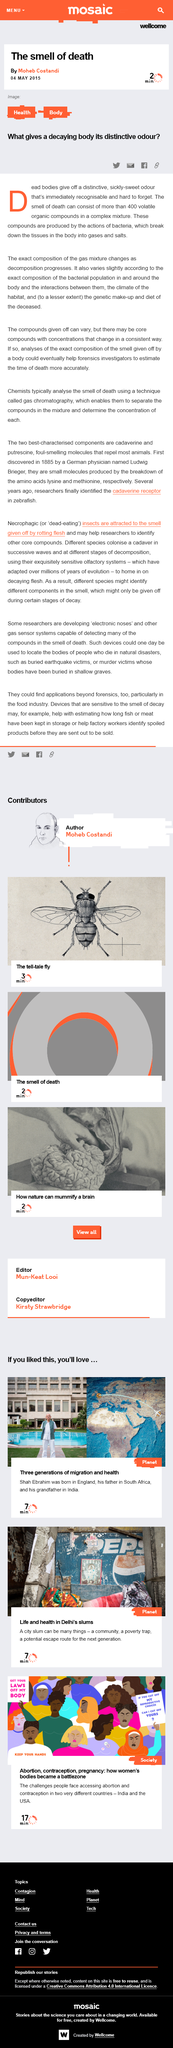Highlight a few significant elements in this photo. Declarative: Decaying bodies emit a distinctive odor. The smell of death can consist of over 400 organic compounds. The article on the smell of death was written by Moheb Costandi. 